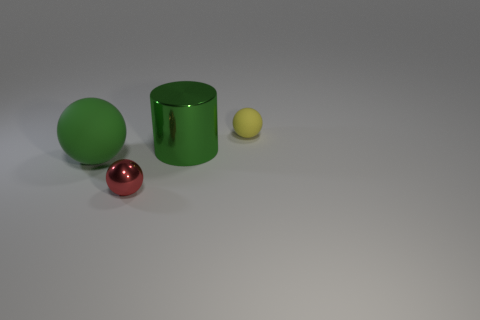Add 3 small spheres. How many objects exist? 7 Subtract all balls. How many objects are left? 1 Subtract 0 green cubes. How many objects are left? 4 Subtract all large purple metallic spheres. Subtract all rubber spheres. How many objects are left? 2 Add 1 rubber spheres. How many rubber spheres are left? 3 Add 2 tiny yellow rubber cylinders. How many tiny yellow rubber cylinders exist? 2 